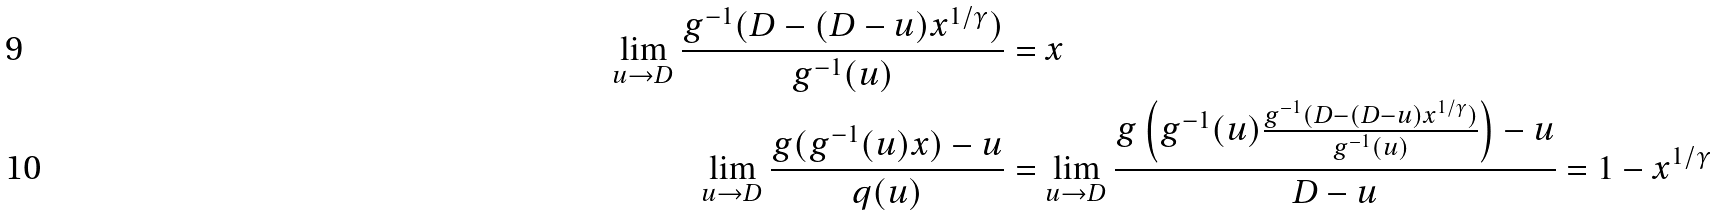Convert formula to latex. <formula><loc_0><loc_0><loc_500><loc_500>\lim _ { u \to D } \frac { g ^ { - 1 } ( D - ( D - u ) x ^ { 1 / \gamma } ) } { g ^ { - 1 } ( u ) } & = x \\ \lim _ { u \to D } \frac { g ( g ^ { - 1 } ( u ) x ) - u } { q ( u ) } & = \lim _ { u \to D } \frac { g \left ( g ^ { - 1 } ( u ) \frac { g ^ { - 1 } ( D - ( D - u ) x ^ { 1 / \gamma } ) } { g ^ { - 1 } ( u ) } \right ) - u } { D - u } = 1 - x ^ { 1 / \gamma }</formula> 